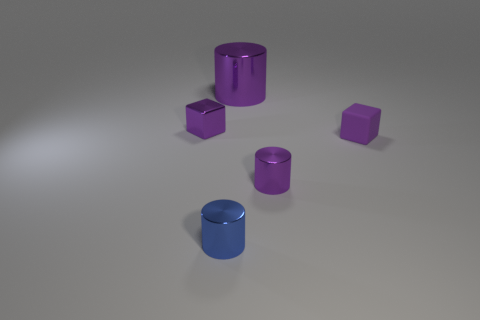There is a matte object that is the same size as the blue metallic cylinder; what color is it?
Keep it short and to the point. Purple. Does the shiny thing that is right of the big thing have the same shape as the big purple object?
Provide a succinct answer. Yes. There is a tiny cylinder that is on the right side of the tiny blue thing that is in front of the cube in front of the metal cube; what is its color?
Offer a terse response. Purple. Are there any cylinders?
Your answer should be very brief. Yes. How many other objects are the same size as the blue thing?
Offer a very short reply. 3. Do the small shiny cube and the tiny cube right of the purple metal block have the same color?
Provide a short and direct response. Yes. What number of things are either purple matte balls or tiny shiny cylinders?
Keep it short and to the point. 2. Is there any other thing that is the same color as the big metallic object?
Keep it short and to the point. Yes. Is the small blue object made of the same material as the small cylinder on the right side of the tiny blue thing?
Your answer should be very brief. Yes. What shape is the metallic object behind the purple cube behind the small rubber block?
Your response must be concise. Cylinder. 